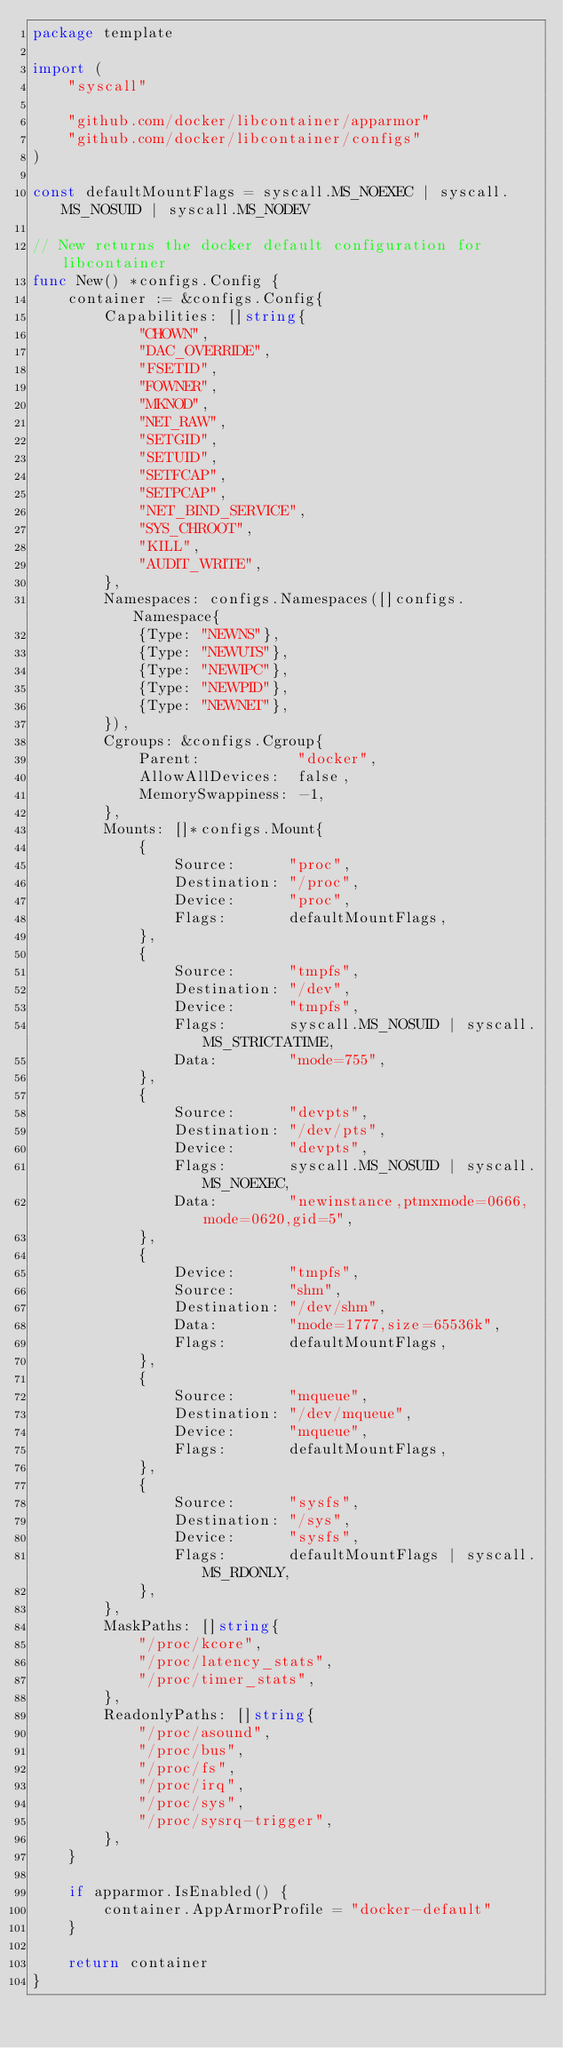<code> <loc_0><loc_0><loc_500><loc_500><_Go_>package template

import (
	"syscall"

	"github.com/docker/libcontainer/apparmor"
	"github.com/docker/libcontainer/configs"
)

const defaultMountFlags = syscall.MS_NOEXEC | syscall.MS_NOSUID | syscall.MS_NODEV

// New returns the docker default configuration for libcontainer
func New() *configs.Config {
	container := &configs.Config{
		Capabilities: []string{
			"CHOWN",
			"DAC_OVERRIDE",
			"FSETID",
			"FOWNER",
			"MKNOD",
			"NET_RAW",
			"SETGID",
			"SETUID",
			"SETFCAP",
			"SETPCAP",
			"NET_BIND_SERVICE",
			"SYS_CHROOT",
			"KILL",
			"AUDIT_WRITE",
		},
		Namespaces: configs.Namespaces([]configs.Namespace{
			{Type: "NEWNS"},
			{Type: "NEWUTS"},
			{Type: "NEWIPC"},
			{Type: "NEWPID"},
			{Type: "NEWNET"},
		}),
		Cgroups: &configs.Cgroup{
			Parent:           "docker",
			AllowAllDevices:  false,
			MemorySwappiness: -1,
		},
		Mounts: []*configs.Mount{
			{
				Source:      "proc",
				Destination: "/proc",
				Device:      "proc",
				Flags:       defaultMountFlags,
			},
			{
				Source:      "tmpfs",
				Destination: "/dev",
				Device:      "tmpfs",
				Flags:       syscall.MS_NOSUID | syscall.MS_STRICTATIME,
				Data:        "mode=755",
			},
			{
				Source:      "devpts",
				Destination: "/dev/pts",
				Device:      "devpts",
				Flags:       syscall.MS_NOSUID | syscall.MS_NOEXEC,
				Data:        "newinstance,ptmxmode=0666,mode=0620,gid=5",
			},
			{
				Device:      "tmpfs",
				Source:      "shm",
				Destination: "/dev/shm",
				Data:        "mode=1777,size=65536k",
				Flags:       defaultMountFlags,
			},
			{
				Source:      "mqueue",
				Destination: "/dev/mqueue",
				Device:      "mqueue",
				Flags:       defaultMountFlags,
			},
			{
				Source:      "sysfs",
				Destination: "/sys",
				Device:      "sysfs",
				Flags:       defaultMountFlags | syscall.MS_RDONLY,
			},
		},
		MaskPaths: []string{
			"/proc/kcore",
			"/proc/latency_stats",
			"/proc/timer_stats",
		},
		ReadonlyPaths: []string{
			"/proc/asound",
			"/proc/bus",
			"/proc/fs",
			"/proc/irq",
			"/proc/sys",
			"/proc/sysrq-trigger",
		},
	}

	if apparmor.IsEnabled() {
		container.AppArmorProfile = "docker-default"
	}

	return container
}
</code> 